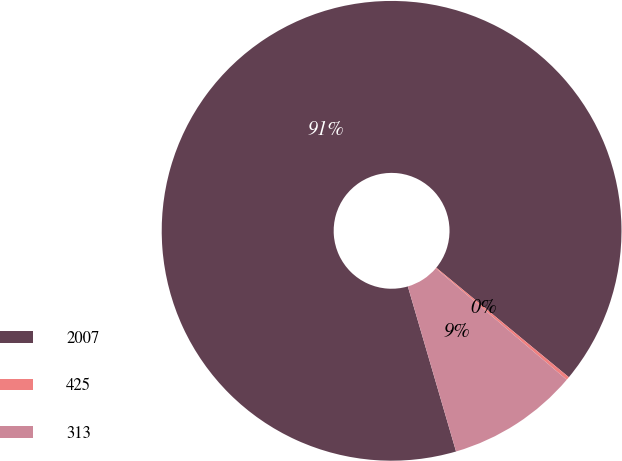<chart> <loc_0><loc_0><loc_500><loc_500><pie_chart><fcel>2007<fcel>425<fcel>313<nl><fcel>90.51%<fcel>0.23%<fcel>9.26%<nl></chart> 